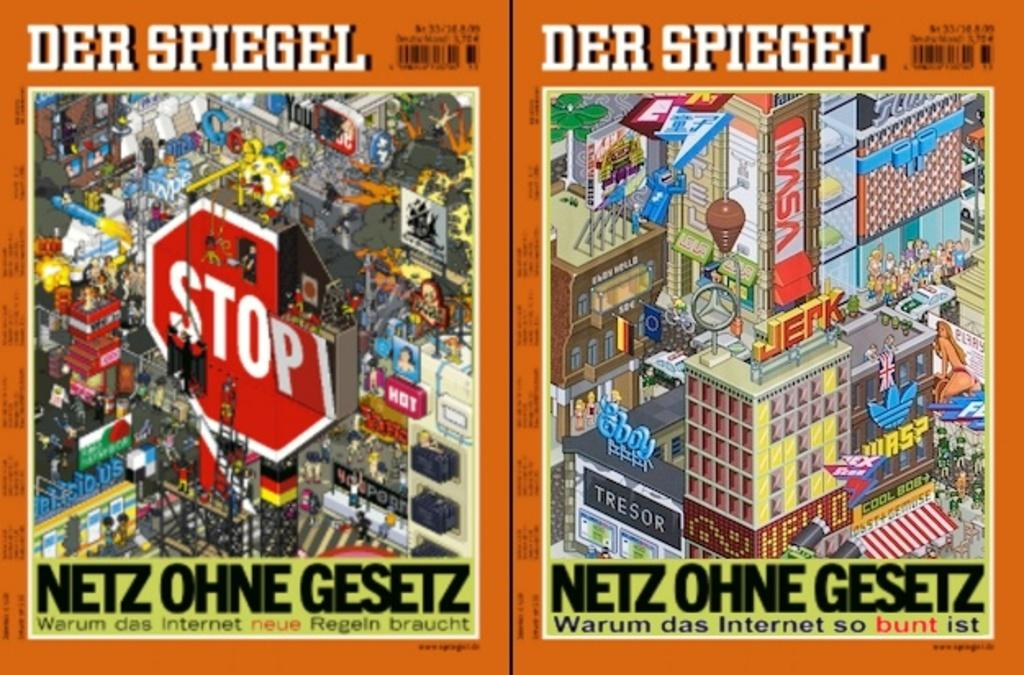<image>
Describe the image concisely. A magazine cover in German with a Stop sign on one side. 